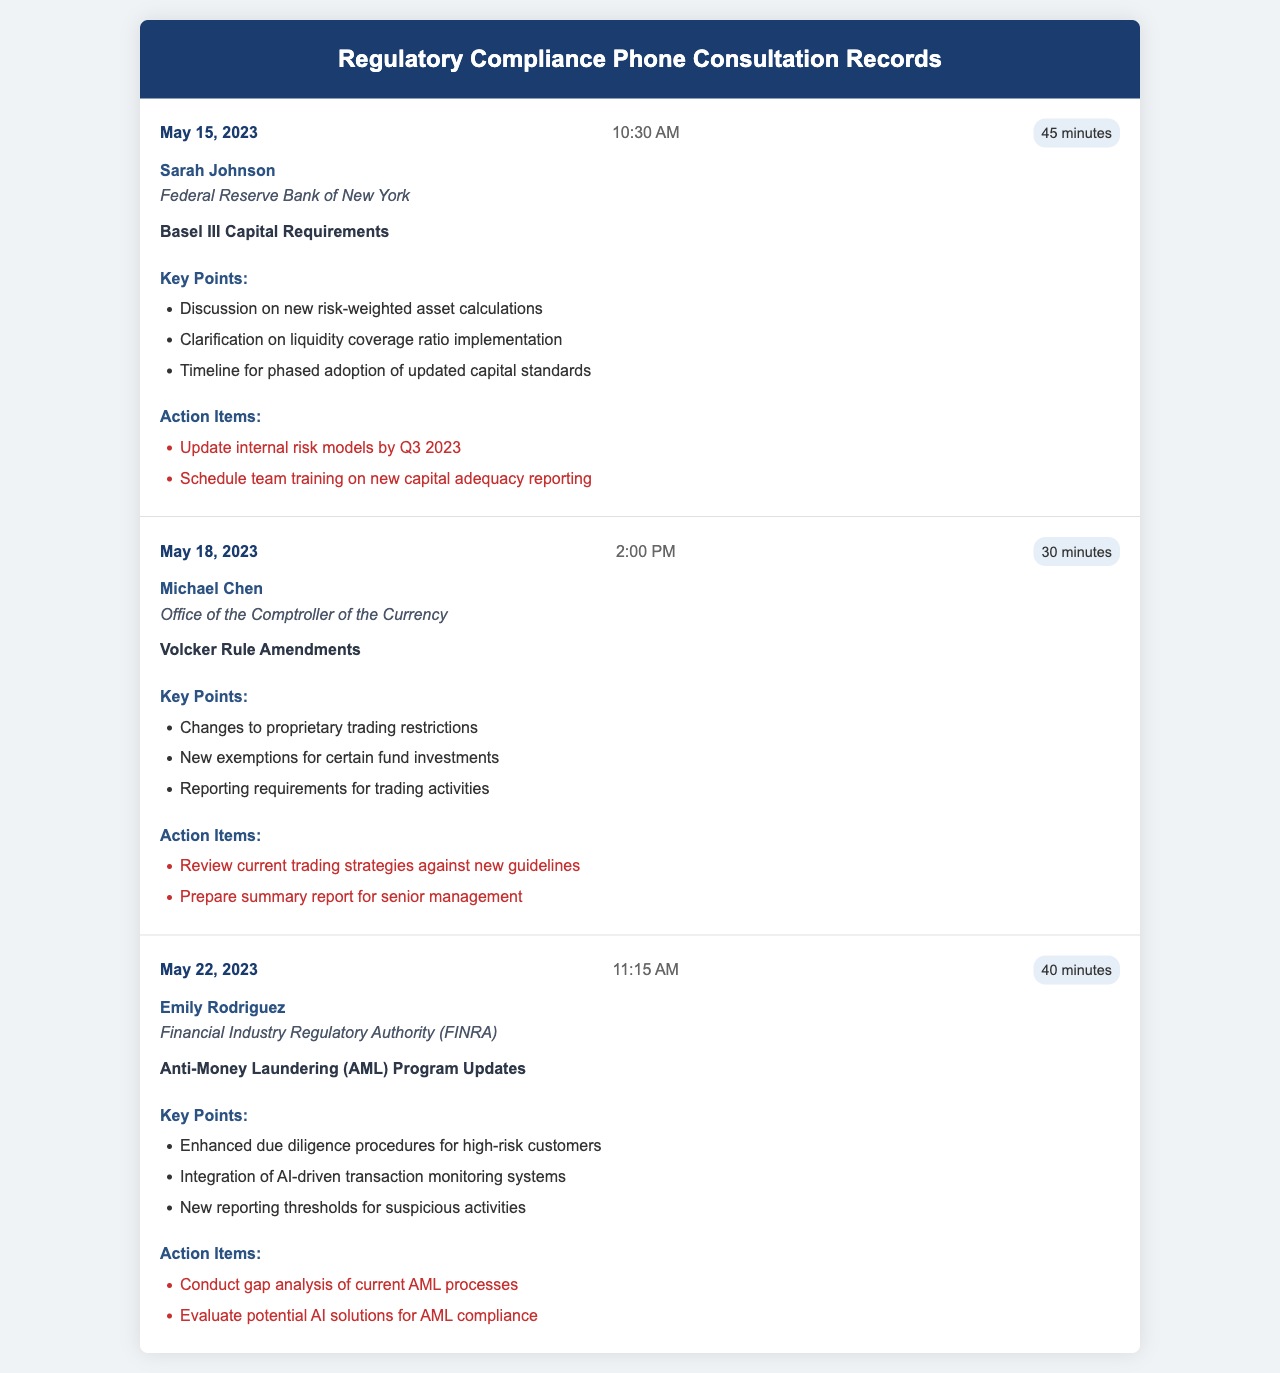What is the date of the consultation with Sarah Johnson? The date for the consultation with Sarah Johnson is listed under her record and is May 15, 2023.
Answer: May 15, 2023 What was the duration of the consultation on the Volcker Rule Amendments? The duration is specified in the consultation record for Michael Chen regarding the Volcker Rule Amendments, which is 30 minutes.
Answer: 30 minutes Who conducted the consultation on Anti-Money Laundering program updates? The officer conducting the consultation on Anti-Money Laundering program updates is mentioned in the record as Emily Rodriguez.
Answer: Emily Rodriguez What key point was discussed regarding Basel III in the consultation? One key point discussed was the clarification on liquidity coverage ratio implementation, listed in the key points for Sarah Johnson's consultation.
Answer: Clarification on liquidity coverage ratio implementation What action item is associated with the proposed changes to proprietary trading? One action item states to review current trading strategies against new guidelines, which relates to the changes discussed during Michael Chen's consultation.
Answer: Review current trading strategies against new guidelines 